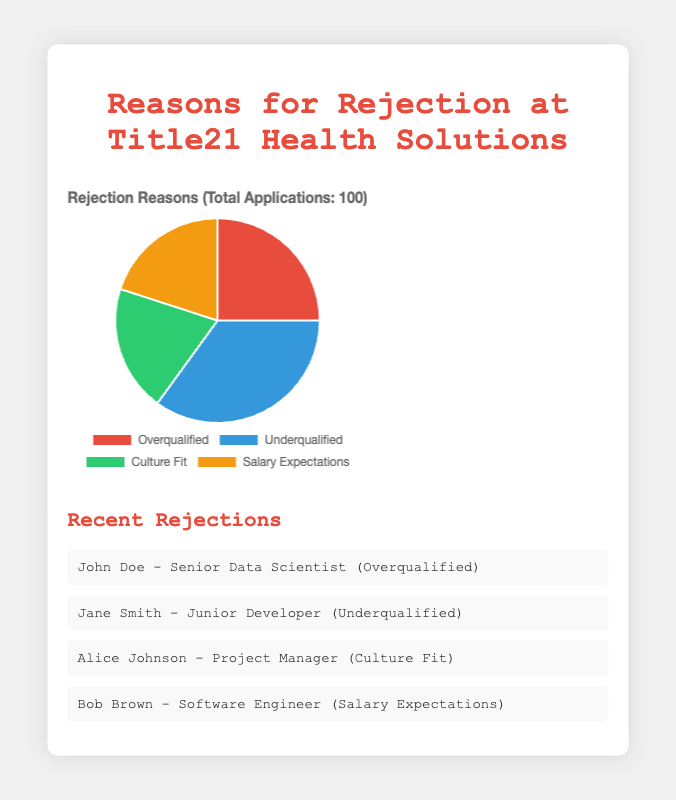What is the most common reason for rejection? The largest segment of the pie chart represents the most common reason for rejection. The segment labeled "Underqualified" occupies 35% of the pie chart, which is the highest percentage among all categories.
Answer: Underqualified Which two reasons have the same percentage of rejection? The pie chart shows four different segments with their respective percentages. By examining the segments, you'll see that both "Culture Fit" and "Salary Expectations" each have a percentage of 20%.
Answer: Culture Fit and Salary Expectations What is the difference in percentage between the most and least common reasons for rejection? First, identify the most common and the least common reasons from the chart: "Underqualified" is 35%, and "Culture Fit" is 20%. The difference is calculated as 35% - 20% = 15%.
Answer: 15% What proportion of the rejection reasons are related to qualifications (either overqualified or underqualified)? Add the percentages for "Overqualified" and "Underqualified": 25% + 35% = 60%. Thus, 60% of the rejections are related to qualifications.
Answer: 60% Are more applicants rejected for being overqualified or not meeting salary expectations? Compare the percentages: "Overqualified" has 25% and "Salary Expectations" has 20%. Since 25% is greater than 20%, more applicants are rejected for being overqualified.
Answer: Overqualified If Title21 Health Solutions received 200 applications in total, how many applicants were rejected for being a bad fit for the company culture? Use the percentage of rejections for "Culture Fit," which is 20%. Multiply 20% by the total number of applications: 0.20 * 200 = 40
Answer: 40 What is the combined percentage of rejections for reasons other than qualifications? Add the percentages for "Culture Fit" and "Salary Expectations": 20% + 20% = 40%.
Answer: 40% Which segment is represented by a red color in the pie chart? Visual inspection of the pie chart shows that the "Overqualified" segment is depicted using the red color.
Answer: Overqualified Is the percentage of applicants rejected for inadequate qualifications greater than the combined percentage of those rejected for culture fit and salary expectations? Compare the percentage of "Underqualified" (35%) with the sum of "Culture Fit" and "Salary Expectations" (20% + 20%), which equals 40%. Since 35% is less than 40%, the percentage is not greater.
Answer: No 